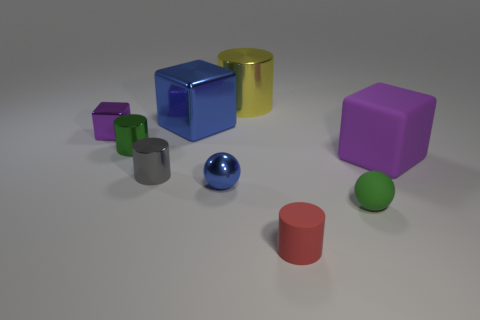Is the shape of the big yellow object the same as the small purple metal object?
Your response must be concise. No. Is there any other thing that is the same color as the small rubber sphere?
Offer a very short reply. Yes. What is the color of the matte object that is the same shape as the tiny blue shiny thing?
Keep it short and to the point. Green. Is the number of small metal objects that are behind the big yellow metal object greater than the number of purple cubes?
Your answer should be very brief. No. What is the color of the rubber object that is behind the blue metal sphere?
Provide a succinct answer. Purple. Does the yellow cylinder have the same size as the red thing?
Your answer should be compact. No. What size is the purple metal cube?
Provide a succinct answer. Small. The metal object that is the same color as the large rubber cube is what shape?
Ensure brevity in your answer.  Cube. Is the number of small green metal cylinders greater than the number of large blue rubber spheres?
Your answer should be very brief. Yes. What is the color of the shiny cube on the right side of the metal block that is left of the shiny cylinder that is in front of the green metallic object?
Provide a short and direct response. Blue. 